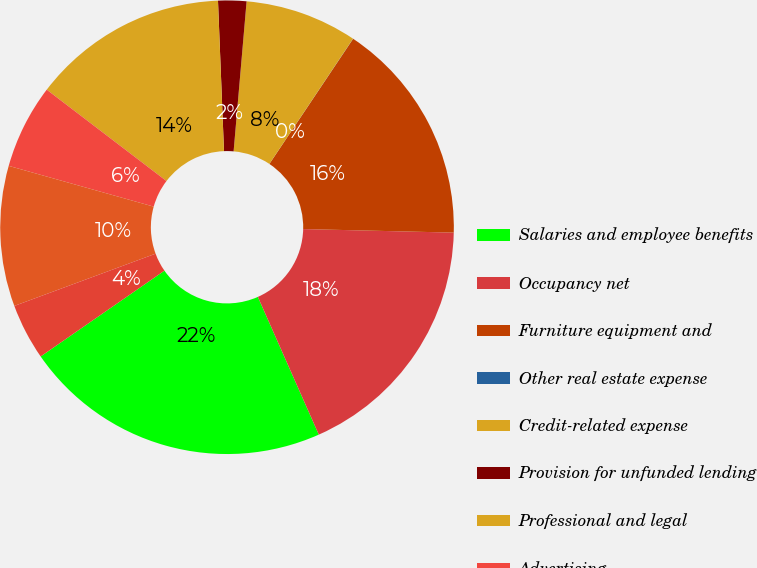<chart> <loc_0><loc_0><loc_500><loc_500><pie_chart><fcel>Salaries and employee benefits<fcel>Occupancy net<fcel>Furniture equipment and<fcel>Other real estate expense<fcel>Credit-related expense<fcel>Provision for unfunded lending<fcel>Professional and legal<fcel>Advertising<fcel>FDIC premiums<fcel>Amortization of core deposit<nl><fcel>21.98%<fcel>17.99%<fcel>15.99%<fcel>0.01%<fcel>8.0%<fcel>2.01%<fcel>13.99%<fcel>6.01%<fcel>10.0%<fcel>4.01%<nl></chart> 